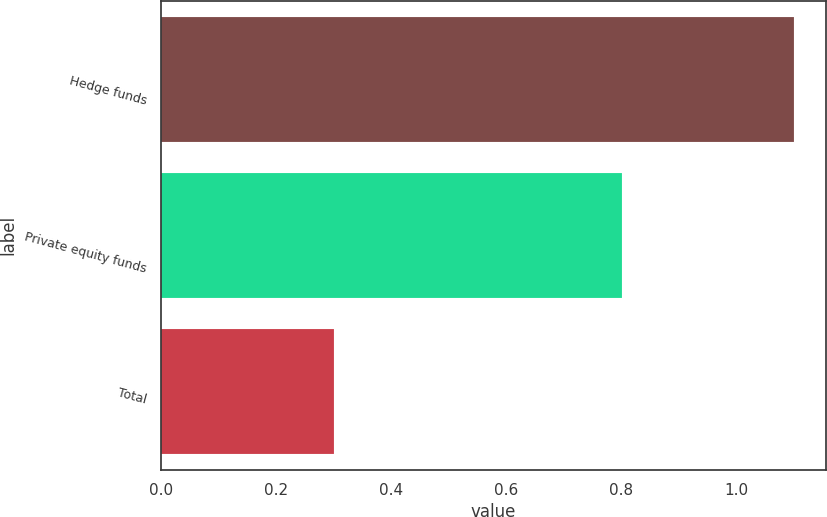<chart> <loc_0><loc_0><loc_500><loc_500><bar_chart><fcel>Hedge funds<fcel>Private equity funds<fcel>Total<nl><fcel>1.1<fcel>0.8<fcel>0.3<nl></chart> 